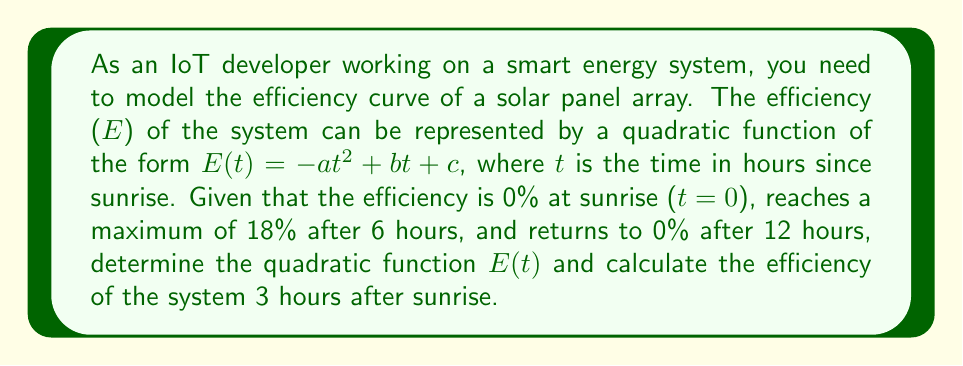Solve this math problem. Let's approach this step-by-step:

1) The general form of the quadratic function is:
   $$E(t) = -at^2 + bt + c$$

2) We have three conditions:
   a) $E(0) = 0$ (efficiency is 0% at sunrise)
   b) $E(6) = 18$ (maximum efficiency of 18% after 6 hours)
   c) $E(12) = 0$ (efficiency returns to 0% after 12 hours)

3) Using condition (a):
   $E(0) = -a(0)^2 + b(0) + c = c = 0$
   So, $c = 0$ and our function becomes:
   $$E(t) = -at^2 + bt$$

4) Using condition (c):
   $E(12) = -a(12)^2 + b(12) = 0$
   $-144a + 12b = 0$
   $12b = 144a$
   $b = 12a$

5) Substituting this into our function:
   $$E(t) = -at^2 + 12at$$

6) Now, using condition (b):
   $E(6) = -a(6)^2 + 12a(6) = 18$
   $-36a + 72a = 18$
   $36a = 18$
   $a = 0.5$

7) Therefore, our final function is:
   $$E(t) = -0.5t^2 + 6t$$

8) To find the efficiency after 3 hours, we substitute t = 3:
   $E(3) = -0.5(3)^2 + 6(3)$
   $= -4.5 + 18$
   $= 13.5$
Answer: The efficiency function is $E(t) = -0.5t^2 + 6t$, and the efficiency 3 hours after sunrise is 13.5%. 